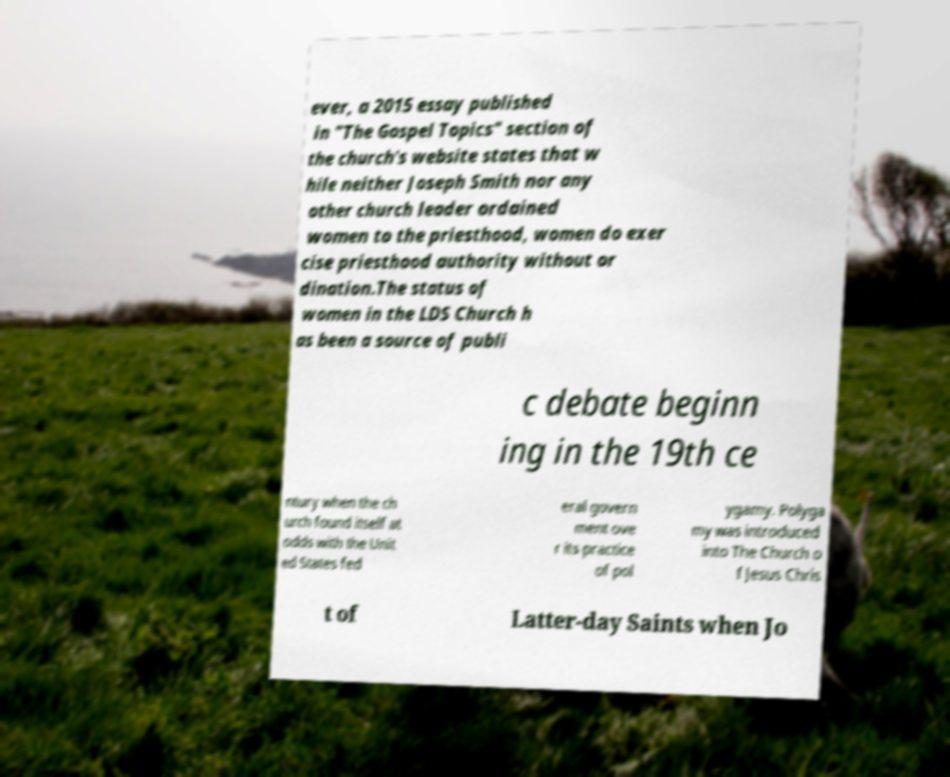Please read and relay the text visible in this image. What does it say? ever, a 2015 essay published in "The Gospel Topics" section of the church's website states that w hile neither Joseph Smith nor any other church leader ordained women to the priesthood, women do exer cise priesthood authority without or dination.The status of women in the LDS Church h as been a source of publi c debate beginn ing in the 19th ce ntury when the ch urch found itself at odds with the Unit ed States fed eral govern ment ove r its practice of pol ygamy. Polyga my was introduced into The Church o f Jesus Chris t of Latter-day Saints when Jo 